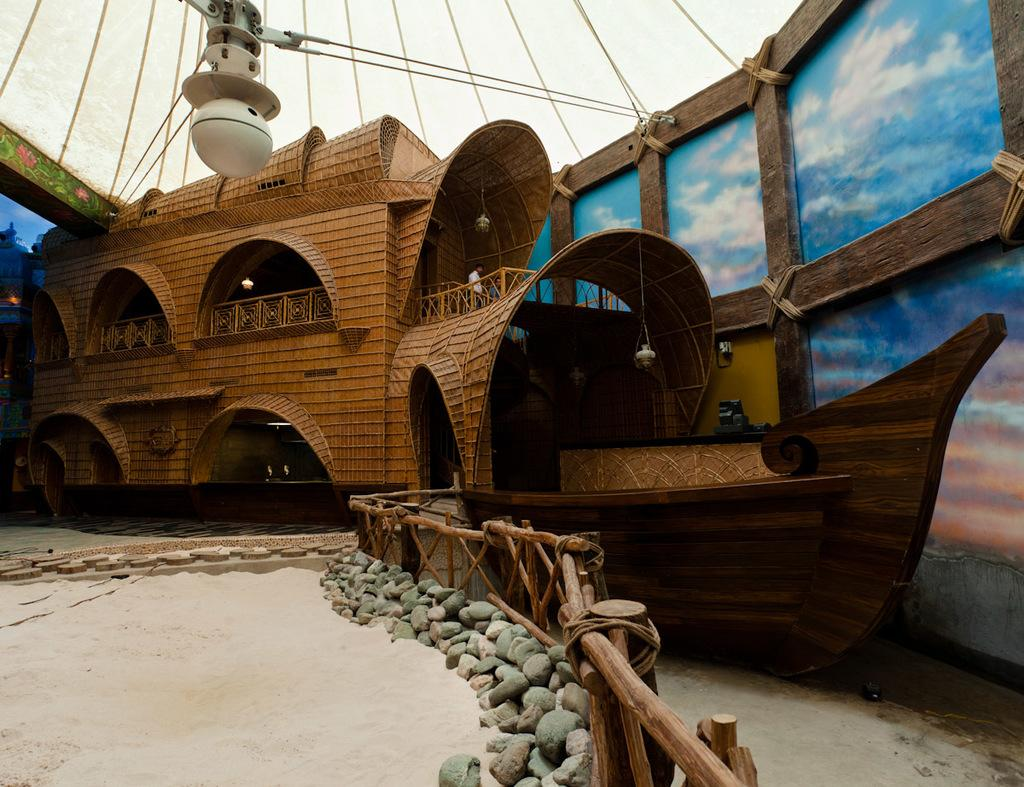What is the main subject of the image? There is a ship in the image. What is located beside the ship? The ship is beside a wooden wall. What type of structure provides shelter in the image? There is a roof for shelter in the image. What can be found at the bottom of the image? Stones are present at the bottom of the image. What type of barrier is visible in the image? There is a fence in the image. What type of song can be heard coming from the ship in the image? There is no indication in the image that a song is being played or sung on the ship, so it's not possible to determine what, if any, song might be heard. 